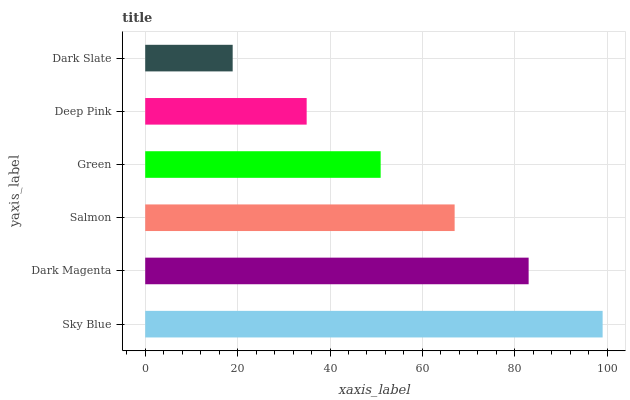Is Dark Slate the minimum?
Answer yes or no. Yes. Is Sky Blue the maximum?
Answer yes or no. Yes. Is Dark Magenta the minimum?
Answer yes or no. No. Is Dark Magenta the maximum?
Answer yes or no. No. Is Sky Blue greater than Dark Magenta?
Answer yes or no. Yes. Is Dark Magenta less than Sky Blue?
Answer yes or no. Yes. Is Dark Magenta greater than Sky Blue?
Answer yes or no. No. Is Sky Blue less than Dark Magenta?
Answer yes or no. No. Is Salmon the high median?
Answer yes or no. Yes. Is Green the low median?
Answer yes or no. Yes. Is Dark Slate the high median?
Answer yes or no. No. Is Deep Pink the low median?
Answer yes or no. No. 